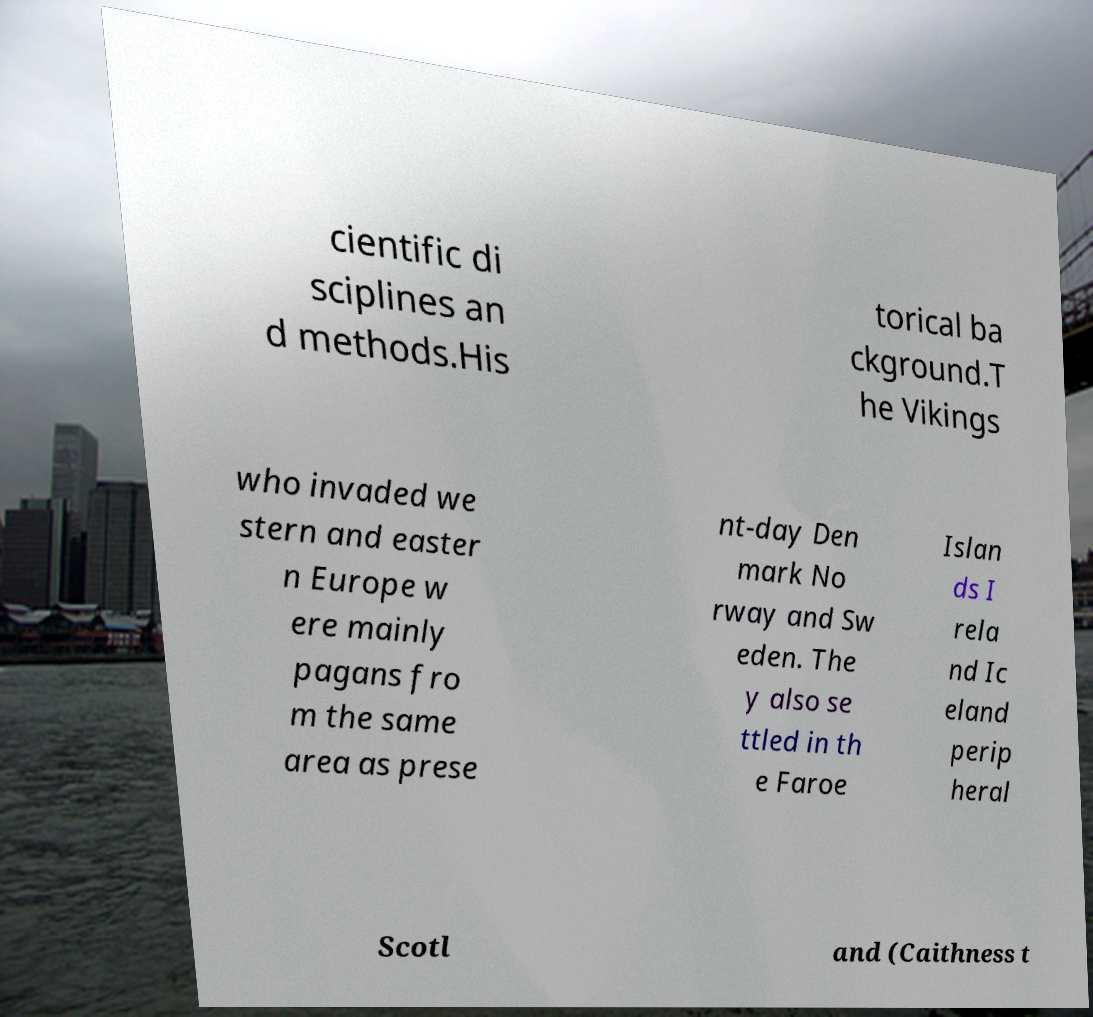Please read and relay the text visible in this image. What does it say? cientific di sciplines an d methods.His torical ba ckground.T he Vikings who invaded we stern and easter n Europe w ere mainly pagans fro m the same area as prese nt-day Den mark No rway and Sw eden. The y also se ttled in th e Faroe Islan ds I rela nd Ic eland perip heral Scotl and (Caithness t 